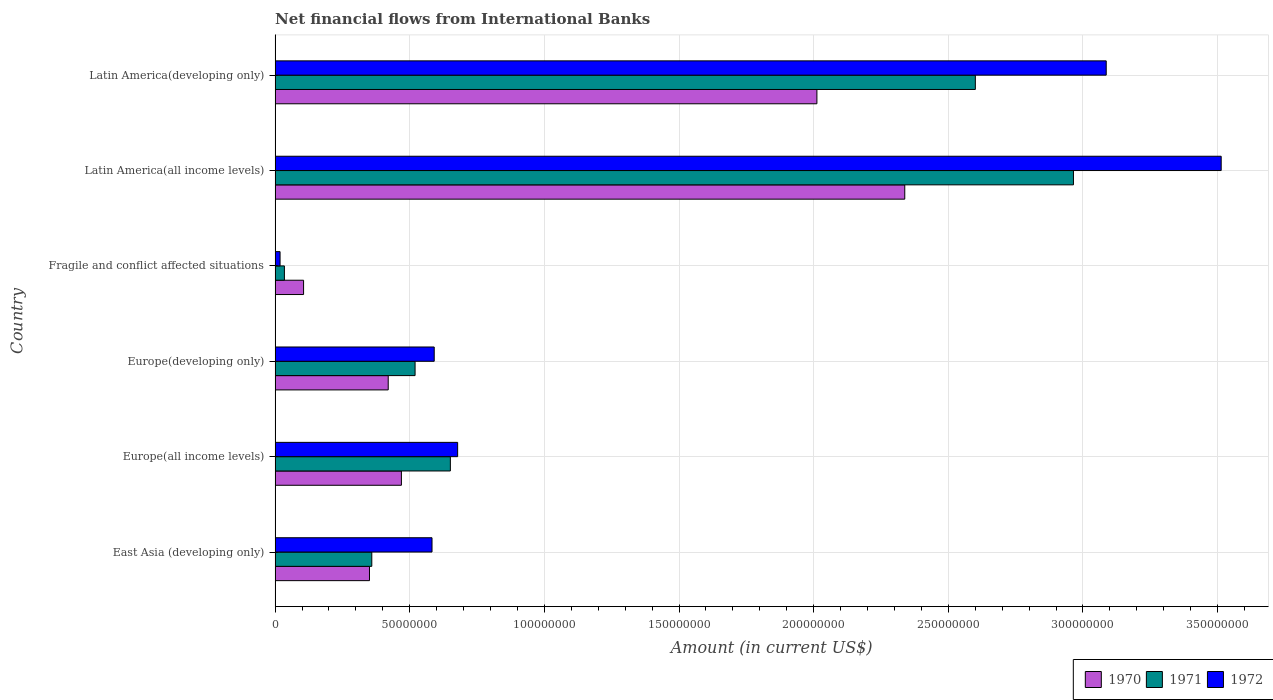Are the number of bars per tick equal to the number of legend labels?
Offer a very short reply. Yes. Are the number of bars on each tick of the Y-axis equal?
Make the answer very short. Yes. How many bars are there on the 4th tick from the top?
Keep it short and to the point. 3. How many bars are there on the 4th tick from the bottom?
Give a very brief answer. 3. What is the label of the 1st group of bars from the top?
Give a very brief answer. Latin America(developing only). What is the net financial aid flows in 1970 in Latin America(developing only)?
Your answer should be very brief. 2.01e+08. Across all countries, what is the maximum net financial aid flows in 1972?
Keep it short and to the point. 3.51e+08. Across all countries, what is the minimum net financial aid flows in 1971?
Your answer should be compact. 3.47e+06. In which country was the net financial aid flows in 1970 maximum?
Your response must be concise. Latin America(all income levels). In which country was the net financial aid flows in 1970 minimum?
Ensure brevity in your answer.  Fragile and conflict affected situations. What is the total net financial aid flows in 1970 in the graph?
Offer a terse response. 5.70e+08. What is the difference between the net financial aid flows in 1970 in Europe(all income levels) and that in Europe(developing only)?
Your response must be concise. 4.90e+06. What is the difference between the net financial aid flows in 1971 in Latin America(all income levels) and the net financial aid flows in 1970 in Fragile and conflict affected situations?
Make the answer very short. 2.86e+08. What is the average net financial aid flows in 1971 per country?
Give a very brief answer. 1.19e+08. What is the difference between the net financial aid flows in 1970 and net financial aid flows in 1972 in East Asia (developing only)?
Ensure brevity in your answer.  -2.32e+07. In how many countries, is the net financial aid flows in 1972 greater than 140000000 US$?
Ensure brevity in your answer.  2. What is the ratio of the net financial aid flows in 1970 in Europe(all income levels) to that in Latin America(all income levels)?
Offer a terse response. 0.2. Is the net financial aid flows in 1970 in Fragile and conflict affected situations less than that in Latin America(developing only)?
Your response must be concise. Yes. Is the difference between the net financial aid flows in 1970 in East Asia (developing only) and Fragile and conflict affected situations greater than the difference between the net financial aid flows in 1972 in East Asia (developing only) and Fragile and conflict affected situations?
Make the answer very short. No. What is the difference between the highest and the second highest net financial aid flows in 1970?
Provide a succinct answer. 3.26e+07. What is the difference between the highest and the lowest net financial aid flows in 1972?
Your response must be concise. 3.49e+08. In how many countries, is the net financial aid flows in 1970 greater than the average net financial aid flows in 1970 taken over all countries?
Your answer should be compact. 2. Is the sum of the net financial aid flows in 1972 in Fragile and conflict affected situations and Latin America(developing only) greater than the maximum net financial aid flows in 1970 across all countries?
Give a very brief answer. Yes. What does the 1st bar from the top in East Asia (developing only) represents?
Offer a terse response. 1972. Is it the case that in every country, the sum of the net financial aid flows in 1971 and net financial aid flows in 1972 is greater than the net financial aid flows in 1970?
Keep it short and to the point. No. What is the difference between two consecutive major ticks on the X-axis?
Your answer should be very brief. 5.00e+07. Does the graph contain grids?
Keep it short and to the point. Yes. How are the legend labels stacked?
Provide a succinct answer. Horizontal. What is the title of the graph?
Ensure brevity in your answer.  Net financial flows from International Banks. Does "1982" appear as one of the legend labels in the graph?
Offer a very short reply. No. What is the label or title of the Y-axis?
Offer a terse response. Country. What is the Amount (in current US$) in 1970 in East Asia (developing only)?
Your answer should be very brief. 3.51e+07. What is the Amount (in current US$) of 1971 in East Asia (developing only)?
Ensure brevity in your answer.  3.59e+07. What is the Amount (in current US$) in 1972 in East Asia (developing only)?
Provide a short and direct response. 5.83e+07. What is the Amount (in current US$) in 1970 in Europe(all income levels)?
Provide a succinct answer. 4.69e+07. What is the Amount (in current US$) in 1971 in Europe(all income levels)?
Your response must be concise. 6.51e+07. What is the Amount (in current US$) in 1972 in Europe(all income levels)?
Your answer should be compact. 6.78e+07. What is the Amount (in current US$) in 1970 in Europe(developing only)?
Provide a succinct answer. 4.20e+07. What is the Amount (in current US$) in 1971 in Europe(developing only)?
Provide a short and direct response. 5.20e+07. What is the Amount (in current US$) in 1972 in Europe(developing only)?
Keep it short and to the point. 5.91e+07. What is the Amount (in current US$) of 1970 in Fragile and conflict affected situations?
Ensure brevity in your answer.  1.06e+07. What is the Amount (in current US$) in 1971 in Fragile and conflict affected situations?
Provide a short and direct response. 3.47e+06. What is the Amount (in current US$) of 1972 in Fragile and conflict affected situations?
Your response must be concise. 1.85e+06. What is the Amount (in current US$) of 1970 in Latin America(all income levels)?
Offer a very short reply. 2.34e+08. What is the Amount (in current US$) in 1971 in Latin America(all income levels)?
Offer a very short reply. 2.96e+08. What is the Amount (in current US$) in 1972 in Latin America(all income levels)?
Provide a succinct answer. 3.51e+08. What is the Amount (in current US$) of 1970 in Latin America(developing only)?
Provide a succinct answer. 2.01e+08. What is the Amount (in current US$) in 1971 in Latin America(developing only)?
Your response must be concise. 2.60e+08. What is the Amount (in current US$) in 1972 in Latin America(developing only)?
Keep it short and to the point. 3.09e+08. Across all countries, what is the maximum Amount (in current US$) of 1970?
Make the answer very short. 2.34e+08. Across all countries, what is the maximum Amount (in current US$) of 1971?
Provide a succinct answer. 2.96e+08. Across all countries, what is the maximum Amount (in current US$) of 1972?
Your response must be concise. 3.51e+08. Across all countries, what is the minimum Amount (in current US$) of 1970?
Your answer should be very brief. 1.06e+07. Across all countries, what is the minimum Amount (in current US$) in 1971?
Ensure brevity in your answer.  3.47e+06. Across all countries, what is the minimum Amount (in current US$) in 1972?
Your answer should be very brief. 1.85e+06. What is the total Amount (in current US$) of 1970 in the graph?
Make the answer very short. 5.70e+08. What is the total Amount (in current US$) in 1971 in the graph?
Keep it short and to the point. 7.13e+08. What is the total Amount (in current US$) of 1972 in the graph?
Your response must be concise. 8.47e+08. What is the difference between the Amount (in current US$) in 1970 in East Asia (developing only) and that in Europe(all income levels)?
Your response must be concise. -1.19e+07. What is the difference between the Amount (in current US$) in 1971 in East Asia (developing only) and that in Europe(all income levels)?
Make the answer very short. -2.92e+07. What is the difference between the Amount (in current US$) of 1972 in East Asia (developing only) and that in Europe(all income levels)?
Keep it short and to the point. -9.52e+06. What is the difference between the Amount (in current US$) of 1970 in East Asia (developing only) and that in Europe(developing only)?
Your response must be concise. -6.95e+06. What is the difference between the Amount (in current US$) in 1971 in East Asia (developing only) and that in Europe(developing only)?
Provide a short and direct response. -1.61e+07. What is the difference between the Amount (in current US$) in 1972 in East Asia (developing only) and that in Europe(developing only)?
Keep it short and to the point. -8.15e+05. What is the difference between the Amount (in current US$) of 1970 in East Asia (developing only) and that in Fragile and conflict affected situations?
Your answer should be very brief. 2.45e+07. What is the difference between the Amount (in current US$) of 1971 in East Asia (developing only) and that in Fragile and conflict affected situations?
Offer a very short reply. 3.24e+07. What is the difference between the Amount (in current US$) in 1972 in East Asia (developing only) and that in Fragile and conflict affected situations?
Keep it short and to the point. 5.64e+07. What is the difference between the Amount (in current US$) in 1970 in East Asia (developing only) and that in Latin America(all income levels)?
Provide a short and direct response. -1.99e+08. What is the difference between the Amount (in current US$) of 1971 in East Asia (developing only) and that in Latin America(all income levels)?
Offer a terse response. -2.61e+08. What is the difference between the Amount (in current US$) in 1972 in East Asia (developing only) and that in Latin America(all income levels)?
Your response must be concise. -2.93e+08. What is the difference between the Amount (in current US$) of 1970 in East Asia (developing only) and that in Latin America(developing only)?
Keep it short and to the point. -1.66e+08. What is the difference between the Amount (in current US$) in 1971 in East Asia (developing only) and that in Latin America(developing only)?
Your answer should be very brief. -2.24e+08. What is the difference between the Amount (in current US$) of 1972 in East Asia (developing only) and that in Latin America(developing only)?
Make the answer very short. -2.50e+08. What is the difference between the Amount (in current US$) in 1970 in Europe(all income levels) and that in Europe(developing only)?
Make the answer very short. 4.90e+06. What is the difference between the Amount (in current US$) of 1971 in Europe(all income levels) and that in Europe(developing only)?
Your response must be concise. 1.31e+07. What is the difference between the Amount (in current US$) in 1972 in Europe(all income levels) and that in Europe(developing only)?
Offer a very short reply. 8.70e+06. What is the difference between the Amount (in current US$) of 1970 in Europe(all income levels) and that in Fragile and conflict affected situations?
Keep it short and to the point. 3.63e+07. What is the difference between the Amount (in current US$) in 1971 in Europe(all income levels) and that in Fragile and conflict affected situations?
Provide a short and direct response. 6.16e+07. What is the difference between the Amount (in current US$) in 1972 in Europe(all income levels) and that in Fragile and conflict affected situations?
Give a very brief answer. 6.59e+07. What is the difference between the Amount (in current US$) in 1970 in Europe(all income levels) and that in Latin America(all income levels)?
Your answer should be compact. -1.87e+08. What is the difference between the Amount (in current US$) in 1971 in Europe(all income levels) and that in Latin America(all income levels)?
Ensure brevity in your answer.  -2.31e+08. What is the difference between the Amount (in current US$) in 1972 in Europe(all income levels) and that in Latin America(all income levels)?
Keep it short and to the point. -2.84e+08. What is the difference between the Amount (in current US$) in 1970 in Europe(all income levels) and that in Latin America(developing only)?
Give a very brief answer. -1.54e+08. What is the difference between the Amount (in current US$) of 1971 in Europe(all income levels) and that in Latin America(developing only)?
Your answer should be very brief. -1.95e+08. What is the difference between the Amount (in current US$) of 1972 in Europe(all income levels) and that in Latin America(developing only)?
Your answer should be very brief. -2.41e+08. What is the difference between the Amount (in current US$) of 1970 in Europe(developing only) and that in Fragile and conflict affected situations?
Ensure brevity in your answer.  3.14e+07. What is the difference between the Amount (in current US$) of 1971 in Europe(developing only) and that in Fragile and conflict affected situations?
Your response must be concise. 4.85e+07. What is the difference between the Amount (in current US$) of 1972 in Europe(developing only) and that in Fragile and conflict affected situations?
Offer a very short reply. 5.72e+07. What is the difference between the Amount (in current US$) of 1970 in Europe(developing only) and that in Latin America(all income levels)?
Your answer should be very brief. -1.92e+08. What is the difference between the Amount (in current US$) of 1971 in Europe(developing only) and that in Latin America(all income levels)?
Your response must be concise. -2.44e+08. What is the difference between the Amount (in current US$) in 1972 in Europe(developing only) and that in Latin America(all income levels)?
Your answer should be compact. -2.92e+08. What is the difference between the Amount (in current US$) in 1970 in Europe(developing only) and that in Latin America(developing only)?
Keep it short and to the point. -1.59e+08. What is the difference between the Amount (in current US$) of 1971 in Europe(developing only) and that in Latin America(developing only)?
Your response must be concise. -2.08e+08. What is the difference between the Amount (in current US$) of 1972 in Europe(developing only) and that in Latin America(developing only)?
Offer a terse response. -2.50e+08. What is the difference between the Amount (in current US$) of 1970 in Fragile and conflict affected situations and that in Latin America(all income levels)?
Your response must be concise. -2.23e+08. What is the difference between the Amount (in current US$) in 1971 in Fragile and conflict affected situations and that in Latin America(all income levels)?
Your response must be concise. -2.93e+08. What is the difference between the Amount (in current US$) in 1972 in Fragile and conflict affected situations and that in Latin America(all income levels)?
Offer a terse response. -3.49e+08. What is the difference between the Amount (in current US$) in 1970 in Fragile and conflict affected situations and that in Latin America(developing only)?
Offer a very short reply. -1.91e+08. What is the difference between the Amount (in current US$) of 1971 in Fragile and conflict affected situations and that in Latin America(developing only)?
Provide a short and direct response. -2.57e+08. What is the difference between the Amount (in current US$) in 1972 in Fragile and conflict affected situations and that in Latin America(developing only)?
Make the answer very short. -3.07e+08. What is the difference between the Amount (in current US$) in 1970 in Latin America(all income levels) and that in Latin America(developing only)?
Your answer should be very brief. 3.26e+07. What is the difference between the Amount (in current US$) of 1971 in Latin America(all income levels) and that in Latin America(developing only)?
Your answer should be very brief. 3.64e+07. What is the difference between the Amount (in current US$) in 1972 in Latin America(all income levels) and that in Latin America(developing only)?
Offer a very short reply. 4.27e+07. What is the difference between the Amount (in current US$) in 1970 in East Asia (developing only) and the Amount (in current US$) in 1971 in Europe(all income levels)?
Keep it short and to the point. -3.00e+07. What is the difference between the Amount (in current US$) in 1970 in East Asia (developing only) and the Amount (in current US$) in 1972 in Europe(all income levels)?
Give a very brief answer. -3.27e+07. What is the difference between the Amount (in current US$) of 1971 in East Asia (developing only) and the Amount (in current US$) of 1972 in Europe(all income levels)?
Your response must be concise. -3.19e+07. What is the difference between the Amount (in current US$) of 1970 in East Asia (developing only) and the Amount (in current US$) of 1971 in Europe(developing only)?
Your answer should be compact. -1.69e+07. What is the difference between the Amount (in current US$) in 1970 in East Asia (developing only) and the Amount (in current US$) in 1972 in Europe(developing only)?
Offer a very short reply. -2.40e+07. What is the difference between the Amount (in current US$) of 1971 in East Asia (developing only) and the Amount (in current US$) of 1972 in Europe(developing only)?
Keep it short and to the point. -2.32e+07. What is the difference between the Amount (in current US$) of 1970 in East Asia (developing only) and the Amount (in current US$) of 1971 in Fragile and conflict affected situations?
Ensure brevity in your answer.  3.16e+07. What is the difference between the Amount (in current US$) in 1970 in East Asia (developing only) and the Amount (in current US$) in 1972 in Fragile and conflict affected situations?
Provide a short and direct response. 3.32e+07. What is the difference between the Amount (in current US$) in 1971 in East Asia (developing only) and the Amount (in current US$) in 1972 in Fragile and conflict affected situations?
Offer a very short reply. 3.41e+07. What is the difference between the Amount (in current US$) of 1970 in East Asia (developing only) and the Amount (in current US$) of 1971 in Latin America(all income levels)?
Ensure brevity in your answer.  -2.61e+08. What is the difference between the Amount (in current US$) of 1970 in East Asia (developing only) and the Amount (in current US$) of 1972 in Latin America(all income levels)?
Keep it short and to the point. -3.16e+08. What is the difference between the Amount (in current US$) of 1971 in East Asia (developing only) and the Amount (in current US$) of 1972 in Latin America(all income levels)?
Your answer should be very brief. -3.15e+08. What is the difference between the Amount (in current US$) of 1970 in East Asia (developing only) and the Amount (in current US$) of 1971 in Latin America(developing only)?
Provide a short and direct response. -2.25e+08. What is the difference between the Amount (in current US$) in 1970 in East Asia (developing only) and the Amount (in current US$) in 1972 in Latin America(developing only)?
Give a very brief answer. -2.74e+08. What is the difference between the Amount (in current US$) of 1971 in East Asia (developing only) and the Amount (in current US$) of 1972 in Latin America(developing only)?
Keep it short and to the point. -2.73e+08. What is the difference between the Amount (in current US$) of 1970 in Europe(all income levels) and the Amount (in current US$) of 1971 in Europe(developing only)?
Provide a succinct answer. -5.08e+06. What is the difference between the Amount (in current US$) in 1970 in Europe(all income levels) and the Amount (in current US$) in 1972 in Europe(developing only)?
Provide a succinct answer. -1.22e+07. What is the difference between the Amount (in current US$) in 1971 in Europe(all income levels) and the Amount (in current US$) in 1972 in Europe(developing only)?
Give a very brief answer. 6.00e+06. What is the difference between the Amount (in current US$) in 1970 in Europe(all income levels) and the Amount (in current US$) in 1971 in Fragile and conflict affected situations?
Ensure brevity in your answer.  4.34e+07. What is the difference between the Amount (in current US$) in 1970 in Europe(all income levels) and the Amount (in current US$) in 1972 in Fragile and conflict affected situations?
Keep it short and to the point. 4.51e+07. What is the difference between the Amount (in current US$) of 1971 in Europe(all income levels) and the Amount (in current US$) of 1972 in Fragile and conflict affected situations?
Provide a succinct answer. 6.32e+07. What is the difference between the Amount (in current US$) of 1970 in Europe(all income levels) and the Amount (in current US$) of 1971 in Latin America(all income levels)?
Offer a very short reply. -2.50e+08. What is the difference between the Amount (in current US$) in 1970 in Europe(all income levels) and the Amount (in current US$) in 1972 in Latin America(all income levels)?
Give a very brief answer. -3.04e+08. What is the difference between the Amount (in current US$) in 1971 in Europe(all income levels) and the Amount (in current US$) in 1972 in Latin America(all income levels)?
Offer a very short reply. -2.86e+08. What is the difference between the Amount (in current US$) of 1970 in Europe(all income levels) and the Amount (in current US$) of 1971 in Latin America(developing only)?
Keep it short and to the point. -2.13e+08. What is the difference between the Amount (in current US$) of 1970 in Europe(all income levels) and the Amount (in current US$) of 1972 in Latin America(developing only)?
Provide a short and direct response. -2.62e+08. What is the difference between the Amount (in current US$) of 1971 in Europe(all income levels) and the Amount (in current US$) of 1972 in Latin America(developing only)?
Your answer should be very brief. -2.44e+08. What is the difference between the Amount (in current US$) in 1970 in Europe(developing only) and the Amount (in current US$) in 1971 in Fragile and conflict affected situations?
Offer a terse response. 3.85e+07. What is the difference between the Amount (in current US$) in 1970 in Europe(developing only) and the Amount (in current US$) in 1972 in Fragile and conflict affected situations?
Ensure brevity in your answer.  4.02e+07. What is the difference between the Amount (in current US$) in 1971 in Europe(developing only) and the Amount (in current US$) in 1972 in Fragile and conflict affected situations?
Offer a very short reply. 5.01e+07. What is the difference between the Amount (in current US$) in 1970 in Europe(developing only) and the Amount (in current US$) in 1971 in Latin America(all income levels)?
Offer a terse response. -2.54e+08. What is the difference between the Amount (in current US$) of 1970 in Europe(developing only) and the Amount (in current US$) of 1972 in Latin America(all income levels)?
Give a very brief answer. -3.09e+08. What is the difference between the Amount (in current US$) in 1971 in Europe(developing only) and the Amount (in current US$) in 1972 in Latin America(all income levels)?
Ensure brevity in your answer.  -2.99e+08. What is the difference between the Amount (in current US$) of 1970 in Europe(developing only) and the Amount (in current US$) of 1971 in Latin America(developing only)?
Your answer should be very brief. -2.18e+08. What is the difference between the Amount (in current US$) in 1970 in Europe(developing only) and the Amount (in current US$) in 1972 in Latin America(developing only)?
Your response must be concise. -2.67e+08. What is the difference between the Amount (in current US$) in 1971 in Europe(developing only) and the Amount (in current US$) in 1972 in Latin America(developing only)?
Ensure brevity in your answer.  -2.57e+08. What is the difference between the Amount (in current US$) of 1970 in Fragile and conflict affected situations and the Amount (in current US$) of 1971 in Latin America(all income levels)?
Make the answer very short. -2.86e+08. What is the difference between the Amount (in current US$) of 1970 in Fragile and conflict affected situations and the Amount (in current US$) of 1972 in Latin America(all income levels)?
Provide a succinct answer. -3.41e+08. What is the difference between the Amount (in current US$) in 1971 in Fragile and conflict affected situations and the Amount (in current US$) in 1972 in Latin America(all income levels)?
Offer a terse response. -3.48e+08. What is the difference between the Amount (in current US$) in 1970 in Fragile and conflict affected situations and the Amount (in current US$) in 1971 in Latin America(developing only)?
Offer a terse response. -2.49e+08. What is the difference between the Amount (in current US$) in 1970 in Fragile and conflict affected situations and the Amount (in current US$) in 1972 in Latin America(developing only)?
Provide a short and direct response. -2.98e+08. What is the difference between the Amount (in current US$) in 1971 in Fragile and conflict affected situations and the Amount (in current US$) in 1972 in Latin America(developing only)?
Keep it short and to the point. -3.05e+08. What is the difference between the Amount (in current US$) of 1970 in Latin America(all income levels) and the Amount (in current US$) of 1971 in Latin America(developing only)?
Your answer should be very brief. -2.62e+07. What is the difference between the Amount (in current US$) in 1970 in Latin America(all income levels) and the Amount (in current US$) in 1972 in Latin America(developing only)?
Your answer should be compact. -7.48e+07. What is the difference between the Amount (in current US$) of 1971 in Latin America(all income levels) and the Amount (in current US$) of 1972 in Latin America(developing only)?
Provide a succinct answer. -1.22e+07. What is the average Amount (in current US$) of 1970 per country?
Your response must be concise. 9.49e+07. What is the average Amount (in current US$) of 1971 per country?
Your answer should be very brief. 1.19e+08. What is the average Amount (in current US$) in 1972 per country?
Offer a terse response. 1.41e+08. What is the difference between the Amount (in current US$) in 1970 and Amount (in current US$) in 1971 in East Asia (developing only)?
Your answer should be very brief. -8.55e+05. What is the difference between the Amount (in current US$) of 1970 and Amount (in current US$) of 1972 in East Asia (developing only)?
Provide a succinct answer. -2.32e+07. What is the difference between the Amount (in current US$) in 1971 and Amount (in current US$) in 1972 in East Asia (developing only)?
Your answer should be very brief. -2.24e+07. What is the difference between the Amount (in current US$) of 1970 and Amount (in current US$) of 1971 in Europe(all income levels)?
Make the answer very short. -1.82e+07. What is the difference between the Amount (in current US$) in 1970 and Amount (in current US$) in 1972 in Europe(all income levels)?
Keep it short and to the point. -2.09e+07. What is the difference between the Amount (in current US$) in 1971 and Amount (in current US$) in 1972 in Europe(all income levels)?
Make the answer very short. -2.70e+06. What is the difference between the Amount (in current US$) of 1970 and Amount (in current US$) of 1971 in Europe(developing only)?
Provide a short and direct response. -9.98e+06. What is the difference between the Amount (in current US$) of 1970 and Amount (in current US$) of 1972 in Europe(developing only)?
Give a very brief answer. -1.71e+07. What is the difference between the Amount (in current US$) of 1971 and Amount (in current US$) of 1972 in Europe(developing only)?
Provide a succinct answer. -7.10e+06. What is the difference between the Amount (in current US$) of 1970 and Amount (in current US$) of 1971 in Fragile and conflict affected situations?
Ensure brevity in your answer.  7.12e+06. What is the difference between the Amount (in current US$) of 1970 and Amount (in current US$) of 1972 in Fragile and conflict affected situations?
Keep it short and to the point. 8.74e+06. What is the difference between the Amount (in current US$) in 1971 and Amount (in current US$) in 1972 in Fragile and conflict affected situations?
Keep it short and to the point. 1.62e+06. What is the difference between the Amount (in current US$) in 1970 and Amount (in current US$) in 1971 in Latin America(all income levels)?
Your response must be concise. -6.26e+07. What is the difference between the Amount (in current US$) in 1970 and Amount (in current US$) in 1972 in Latin America(all income levels)?
Your response must be concise. -1.18e+08. What is the difference between the Amount (in current US$) of 1971 and Amount (in current US$) of 1972 in Latin America(all income levels)?
Your answer should be very brief. -5.49e+07. What is the difference between the Amount (in current US$) in 1970 and Amount (in current US$) in 1971 in Latin America(developing only)?
Make the answer very short. -5.88e+07. What is the difference between the Amount (in current US$) in 1970 and Amount (in current US$) in 1972 in Latin America(developing only)?
Offer a very short reply. -1.07e+08. What is the difference between the Amount (in current US$) in 1971 and Amount (in current US$) in 1972 in Latin America(developing only)?
Give a very brief answer. -4.86e+07. What is the ratio of the Amount (in current US$) in 1970 in East Asia (developing only) to that in Europe(all income levels)?
Give a very brief answer. 0.75. What is the ratio of the Amount (in current US$) in 1971 in East Asia (developing only) to that in Europe(all income levels)?
Your answer should be very brief. 0.55. What is the ratio of the Amount (in current US$) of 1972 in East Asia (developing only) to that in Europe(all income levels)?
Make the answer very short. 0.86. What is the ratio of the Amount (in current US$) in 1970 in East Asia (developing only) to that in Europe(developing only)?
Your response must be concise. 0.83. What is the ratio of the Amount (in current US$) in 1971 in East Asia (developing only) to that in Europe(developing only)?
Your answer should be compact. 0.69. What is the ratio of the Amount (in current US$) in 1972 in East Asia (developing only) to that in Europe(developing only)?
Provide a short and direct response. 0.99. What is the ratio of the Amount (in current US$) in 1970 in East Asia (developing only) to that in Fragile and conflict affected situations?
Your answer should be very brief. 3.31. What is the ratio of the Amount (in current US$) in 1971 in East Asia (developing only) to that in Fragile and conflict affected situations?
Make the answer very short. 10.36. What is the ratio of the Amount (in current US$) of 1972 in East Asia (developing only) to that in Fragile and conflict affected situations?
Give a very brief answer. 31.54. What is the ratio of the Amount (in current US$) of 1970 in East Asia (developing only) to that in Latin America(all income levels)?
Your answer should be very brief. 0.15. What is the ratio of the Amount (in current US$) in 1971 in East Asia (developing only) to that in Latin America(all income levels)?
Your answer should be very brief. 0.12. What is the ratio of the Amount (in current US$) in 1972 in East Asia (developing only) to that in Latin America(all income levels)?
Keep it short and to the point. 0.17. What is the ratio of the Amount (in current US$) of 1970 in East Asia (developing only) to that in Latin America(developing only)?
Give a very brief answer. 0.17. What is the ratio of the Amount (in current US$) in 1971 in East Asia (developing only) to that in Latin America(developing only)?
Offer a terse response. 0.14. What is the ratio of the Amount (in current US$) of 1972 in East Asia (developing only) to that in Latin America(developing only)?
Keep it short and to the point. 0.19. What is the ratio of the Amount (in current US$) in 1970 in Europe(all income levels) to that in Europe(developing only)?
Offer a terse response. 1.12. What is the ratio of the Amount (in current US$) of 1971 in Europe(all income levels) to that in Europe(developing only)?
Keep it short and to the point. 1.25. What is the ratio of the Amount (in current US$) in 1972 in Europe(all income levels) to that in Europe(developing only)?
Your answer should be compact. 1.15. What is the ratio of the Amount (in current US$) in 1970 in Europe(all income levels) to that in Fragile and conflict affected situations?
Your response must be concise. 4.43. What is the ratio of the Amount (in current US$) in 1971 in Europe(all income levels) to that in Fragile and conflict affected situations?
Your answer should be very brief. 18.78. What is the ratio of the Amount (in current US$) of 1972 in Europe(all income levels) to that in Fragile and conflict affected situations?
Ensure brevity in your answer.  36.69. What is the ratio of the Amount (in current US$) of 1970 in Europe(all income levels) to that in Latin America(all income levels)?
Your answer should be compact. 0.2. What is the ratio of the Amount (in current US$) in 1971 in Europe(all income levels) to that in Latin America(all income levels)?
Provide a short and direct response. 0.22. What is the ratio of the Amount (in current US$) of 1972 in Europe(all income levels) to that in Latin America(all income levels)?
Make the answer very short. 0.19. What is the ratio of the Amount (in current US$) in 1970 in Europe(all income levels) to that in Latin America(developing only)?
Give a very brief answer. 0.23. What is the ratio of the Amount (in current US$) of 1971 in Europe(all income levels) to that in Latin America(developing only)?
Your answer should be compact. 0.25. What is the ratio of the Amount (in current US$) in 1972 in Europe(all income levels) to that in Latin America(developing only)?
Provide a succinct answer. 0.22. What is the ratio of the Amount (in current US$) of 1970 in Europe(developing only) to that in Fragile and conflict affected situations?
Keep it short and to the point. 3.97. What is the ratio of the Amount (in current US$) of 1971 in Europe(developing only) to that in Fragile and conflict affected situations?
Keep it short and to the point. 15. What is the ratio of the Amount (in current US$) in 1972 in Europe(developing only) to that in Fragile and conflict affected situations?
Your answer should be very brief. 31.98. What is the ratio of the Amount (in current US$) of 1970 in Europe(developing only) to that in Latin America(all income levels)?
Make the answer very short. 0.18. What is the ratio of the Amount (in current US$) in 1971 in Europe(developing only) to that in Latin America(all income levels)?
Provide a short and direct response. 0.18. What is the ratio of the Amount (in current US$) of 1972 in Europe(developing only) to that in Latin America(all income levels)?
Your response must be concise. 0.17. What is the ratio of the Amount (in current US$) in 1970 in Europe(developing only) to that in Latin America(developing only)?
Your response must be concise. 0.21. What is the ratio of the Amount (in current US$) in 1971 in Europe(developing only) to that in Latin America(developing only)?
Your answer should be very brief. 0.2. What is the ratio of the Amount (in current US$) of 1972 in Europe(developing only) to that in Latin America(developing only)?
Keep it short and to the point. 0.19. What is the ratio of the Amount (in current US$) of 1970 in Fragile and conflict affected situations to that in Latin America(all income levels)?
Offer a very short reply. 0.05. What is the ratio of the Amount (in current US$) of 1971 in Fragile and conflict affected situations to that in Latin America(all income levels)?
Your response must be concise. 0.01. What is the ratio of the Amount (in current US$) in 1972 in Fragile and conflict affected situations to that in Latin America(all income levels)?
Make the answer very short. 0.01. What is the ratio of the Amount (in current US$) in 1970 in Fragile and conflict affected situations to that in Latin America(developing only)?
Your response must be concise. 0.05. What is the ratio of the Amount (in current US$) of 1971 in Fragile and conflict affected situations to that in Latin America(developing only)?
Your response must be concise. 0.01. What is the ratio of the Amount (in current US$) of 1972 in Fragile and conflict affected situations to that in Latin America(developing only)?
Give a very brief answer. 0.01. What is the ratio of the Amount (in current US$) of 1970 in Latin America(all income levels) to that in Latin America(developing only)?
Ensure brevity in your answer.  1.16. What is the ratio of the Amount (in current US$) in 1971 in Latin America(all income levels) to that in Latin America(developing only)?
Make the answer very short. 1.14. What is the ratio of the Amount (in current US$) of 1972 in Latin America(all income levels) to that in Latin America(developing only)?
Offer a terse response. 1.14. What is the difference between the highest and the second highest Amount (in current US$) of 1970?
Offer a terse response. 3.26e+07. What is the difference between the highest and the second highest Amount (in current US$) in 1971?
Make the answer very short. 3.64e+07. What is the difference between the highest and the second highest Amount (in current US$) in 1972?
Provide a short and direct response. 4.27e+07. What is the difference between the highest and the lowest Amount (in current US$) in 1970?
Give a very brief answer. 2.23e+08. What is the difference between the highest and the lowest Amount (in current US$) of 1971?
Provide a short and direct response. 2.93e+08. What is the difference between the highest and the lowest Amount (in current US$) of 1972?
Make the answer very short. 3.49e+08. 